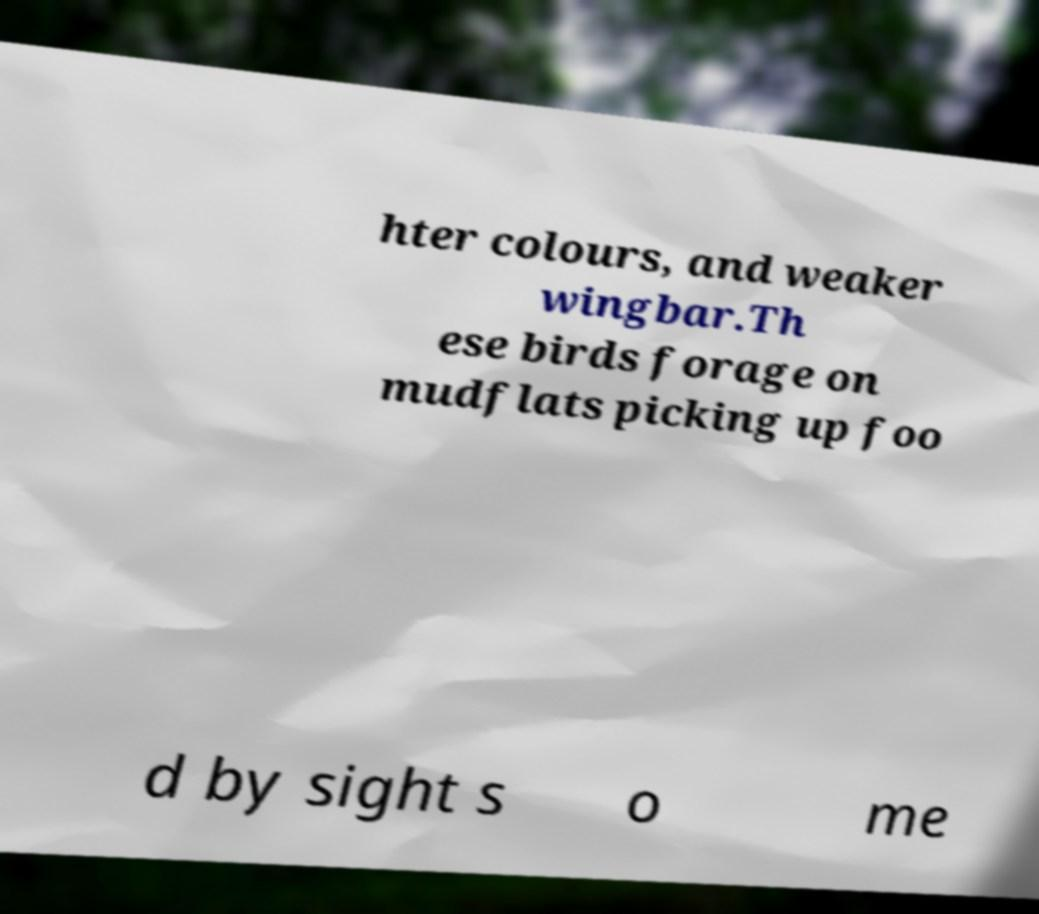There's text embedded in this image that I need extracted. Can you transcribe it verbatim? hter colours, and weaker wingbar.Th ese birds forage on mudflats picking up foo d by sight s o me 